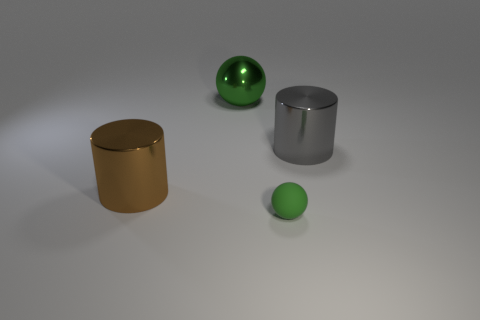There is a big object that is left of the rubber ball and to the right of the large brown shiny cylinder; what color is it? The object you're referring to is indeed the green sphere, which exudes a shiny and smooth appearance, suggesting that it might be made of a material like polished plastic or glass. 